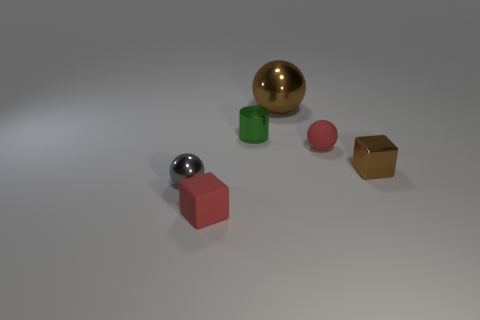Is the color of the small rubber block the same as the tiny cylinder? no 